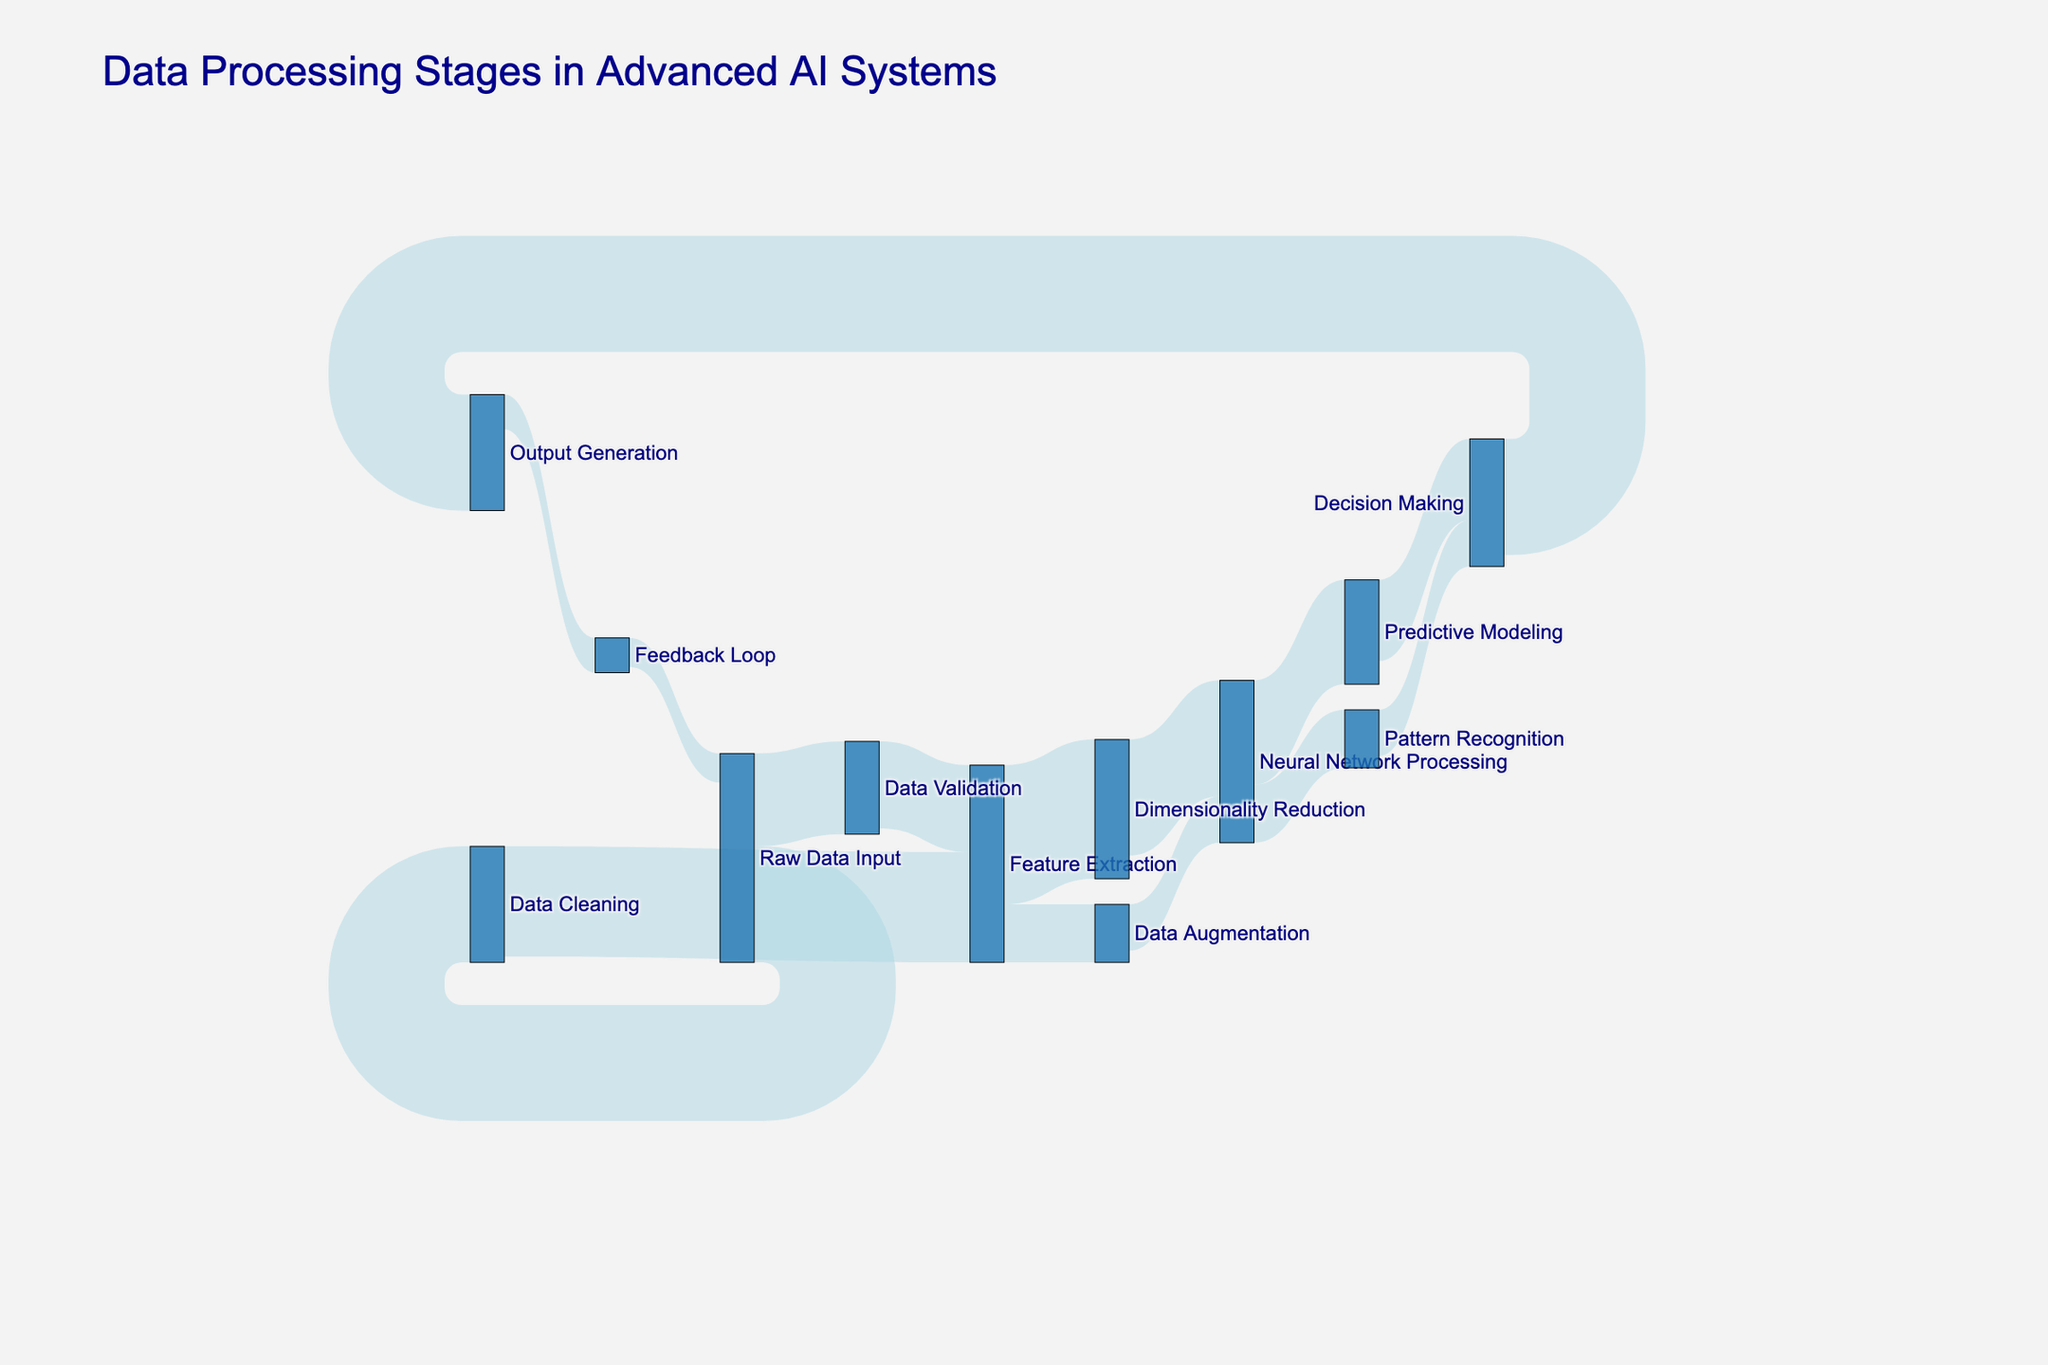Who is processing more data, Data Cleaning or Data Validation? To determine this, we can sum the values flowing into both Data Cleaning and Data Validation stages. Data Cleaning has 1000 units flowing in from Raw Data Input. Data Validation has 800 units flowing in from Raw Data Input. Hence, Data Cleaning processes more data.
Answer: Data Cleaning Which stage has the highest value of data transferred to it? By observing the flows, Feature Extraction has the highest aggregated value with 950 units from Data Cleaning and 750 units from Data Validation, summing up to 1700 units.
Answer: Feature Extraction What is the total value of data flowing from Feature Extraction to other stages? We can sum the values from Feature Extraction to Dimensionality Reduction and Data Augmentation: 1200 (to Dimensionality Reduction) + 500 (to Data Augmentation) = 1700.
Answer: 1700 Which flow has the minimum value in the diagram? By checking all the flows, Feedback Loop to Raw Data Input has the smallest value of 250 units.
Answer: Feedback Loop to Raw Data Input Are there any stages that act as both source and target in the data flow? Yes, Raw Data Input acts as both a source (to Data Cleaning and Data Validation) and a target (from Feedback Loop).
Answer: Yes Between Neural Network Processing and Predictive Modeling, which stage has more data flowing into it? Neural Network Processing gets 1000 from Dimensionality Reduction and 400 from Data Augmentation, summing up to 1400. Predictive Modeling receives 900 from Neural Network Processing. Hence, Neural Network Processing has more.
Answer: Neural Network Processing What is the total value of data flowing from Neural Network Processing to its subsequent stages? Adding the values going to Predictive Modeling and Pattern Recognition: 900 (to Predictive Modeling) + 500 (to Pattern Recognition) = 1400.
Answer: 1400 How much data flows from Decision Making to Output Generation? Referring to the diagram, the flow from Decision Making to Output Generation is 1000 units.
Answer: 1000 